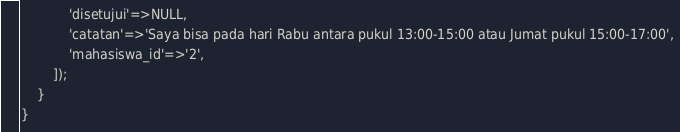<code> <loc_0><loc_0><loc_500><loc_500><_PHP_>            'disetujui'=>NULL,
            'catatan'=>'Saya bisa pada hari Rabu antara pukul 13:00-15:00 atau Jumat pukul 15:00-17:00',
            'mahasiswa_id'=>'2',
        ]);
    }
}
</code> 